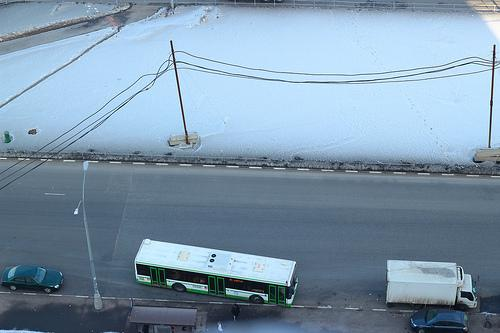Provide a description of the human figures found in the image. There is a person wearing a black jacket, a person standing near the bus, and a person walking along the road. Describe the conditions of the road based on the image. The road has black pavement and snow near it. What is the color of the large transport vehicle in the middle of the street? The large transport vehicle in the middle of the street is white with green doors. List the objects related to lighting and describe them briefly. There is a tall street light that is gray, and a white street lamp. What are the people near the bus doing? There is one person wearing a black jacket, and another person standing near the bus. What color are the doors of the bus, and how many doors are there? The bus has three sets of green doors - the front, middle, and back doors. Describe the unique features of the image with respect to vehicular traffic. The image has an overhead view of vehicles and snow, showcasing a white bus with green doors, a white truck, a green sedan, and a blue car on the pavement. Identify the two prevalent environmental features in the image. The two prevalent environmental features are snow near the road and a building along the road. Estimate the number of vehicles in the overhead view. There are four vehicles in the overhead view. Mention the types of vehicles on the street and their colors. There is a white bus with green doors, a white commercial truck, a green four door sedan, and a blue car. Create a scene that includes an overhead view of vehicles, a bus, and snow. An overhead view of a snow-covered street shows a line of vehicles waiting behind a white bus with green doors as a person in a black jacket crosses the road. What is happening in the image? It shows an overhead view of vehicles and snow-covered road, where a person is standing near a bus, and a white street lamp illuminates the area. What type of street lighting is present in the image? Tall street light and a white street lamp What is the color of the van and what kind of van is it? The van is blue and it is a minivan. What is noticeable about the light pole in the image? The light pole is tall and gray Does the person walking along the road have an umbrella? There is no mention of any person carrying an umbrella in any of the given captions. Which of the following is not present in the image: person walking along the road, white bus with green doors, a building along the road? None, all are present Describe a situation where the white street lamp is involved. The tall, gray light pole and white street lamp illuminate the scene as a person wearing a black jacket stands near a white bus with green doors. Is the street light next to the bus red? There is no mention of a red street light in the image, but there is a tall street light and a white street lamp mentioned. Which vehicle is parked near the bus? A green four door sedan Identify the color of the car and how many doors it has. The car is green and has four doors. Describe the scene involving the bus, a car, and a person. A person wearing a black jacket is standing near a white bus with green doors, and there's a green four door sedan parked close by. Choose the correct phrase from the options: overhead view of some traffic, blue car, tall street light. Overhead view of some traffic What is the color of the truck? The truck is white Is there any snow visible near the road? Yes Can you spot any buildings along the road in the image? Yes, there's a building along the road Provide a vivid description of the commercial truck in the image. A white commercial truck is parked on a black pavement in the street. What are the details of the patch of roadway visible in the image? The visible patch of roadway is black pavement surrounded by snow. What color are the front, middle, and back doors of the bus? Green Give a brief description of the pavement color in this image. The pavement is black Are the bus's windows tinted pink? There is no mention of bus windows tinted pink or any other color, but there are captions describing the white top of the bus and the green doors. Describe the top of the bus. The top of the bus is white Is there a dog running beside the person wearing a black jacket? There is no mention of a dog running or being present in any of the given captions. Can you see a yellow car in the image? There are no yellow cars mentioned in the image, but there are a green four door sedan, a blue car, and a white commercial truck. How would you describe the person wearing a black jacket? A person standing near the bus Can you see any trees in the background near the building along the road? Although there is a mention of a building along the road, there are no trees mentioned in the given captions. 